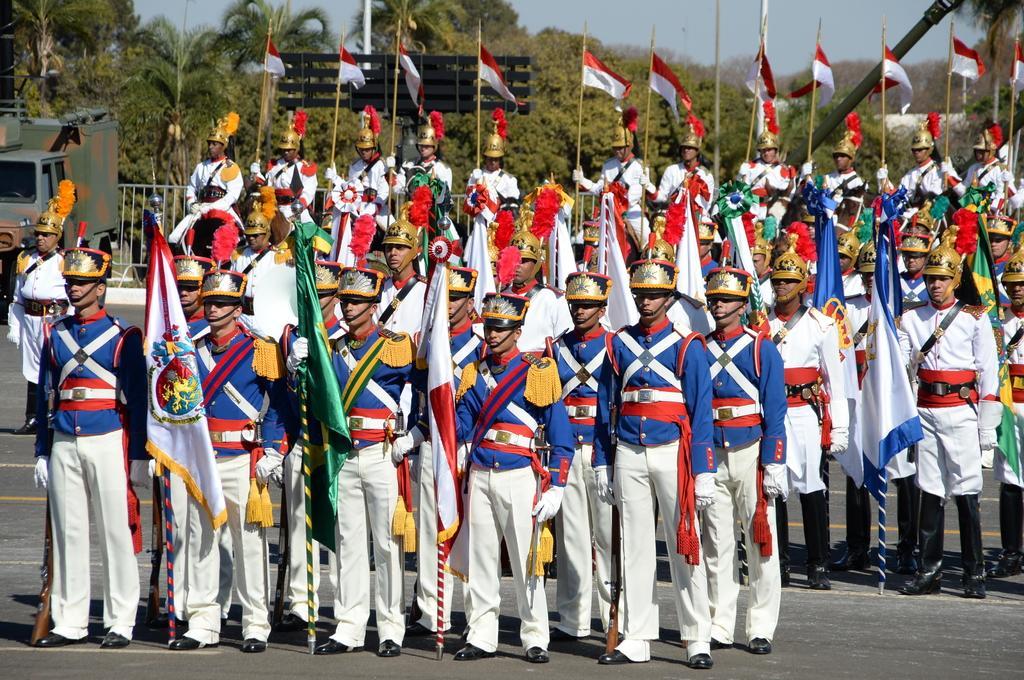Please provide a concise description of this image. Here there are few people wore the same uniform and standing on the ground where few are holding flags and guns in their hand. In the background there are few people standing on the ground and few are sitting on horse and everyone wore the same uniform and holding flags in their hands and every one has helmets on their heads and we can also see a vehicle,fence,poles,name board,trees and sky. 